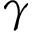Convert formula to latex. <formula><loc_0><loc_0><loc_500><loc_500>\gamma</formula> 